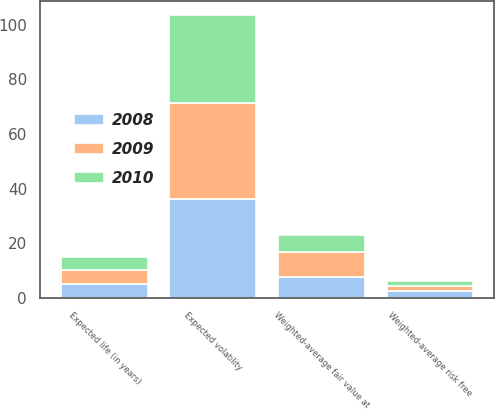<chart> <loc_0><loc_0><loc_500><loc_500><stacked_bar_chart><ecel><fcel>Expected life (in years)<fcel>Weighted-average risk free<fcel>Expected volatility<fcel>Weighted-average fair value at<nl><fcel>2010<fcel>5<fcel>2.03<fcel>32<fcel>6.3<nl><fcel>2008<fcel>5<fcel>2.52<fcel>36<fcel>7.4<nl><fcel>2009<fcel>5<fcel>1.63<fcel>35.5<fcel>9.17<nl></chart> 